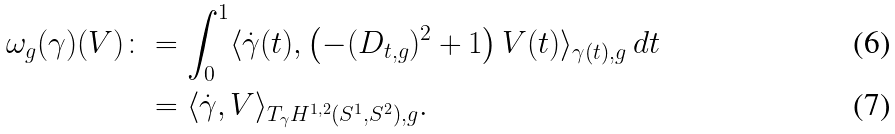Convert formula to latex. <formula><loc_0><loc_0><loc_500><loc_500>\omega _ { g } ( \gamma ) ( V ) \colon & = \int _ { 0 } ^ { 1 } \langle \dot { \gamma } ( t ) , \left ( - ( D _ { t , g } ) ^ { 2 } + 1 \right ) V ( t ) \rangle _ { \gamma ( t ) , g } \, d t \\ & = \langle \dot { \gamma } , V \rangle _ { T _ { \gamma } H ^ { 1 , 2 } ( S ^ { 1 } , S ^ { 2 } ) , g } .</formula> 